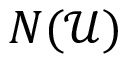<formula> <loc_0><loc_0><loc_500><loc_500>N ( { \mathcal { U } } )</formula> 